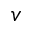Convert formula to latex. <formula><loc_0><loc_0><loc_500><loc_500>v</formula> 